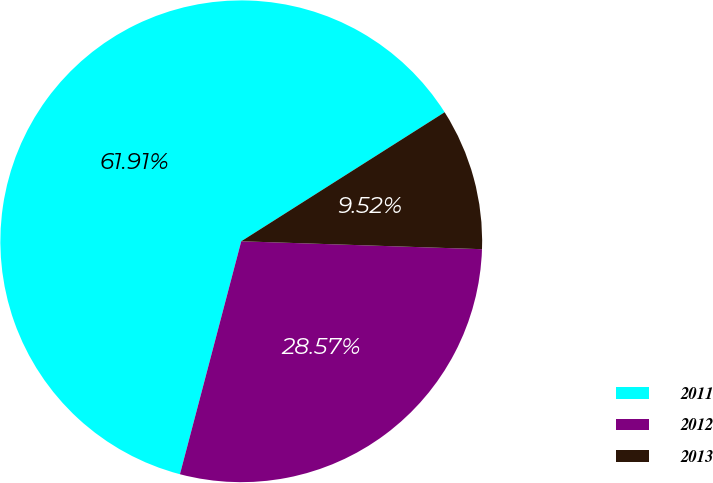Convert chart. <chart><loc_0><loc_0><loc_500><loc_500><pie_chart><fcel>2011<fcel>2012<fcel>2013<nl><fcel>61.9%<fcel>28.57%<fcel>9.52%<nl></chart> 